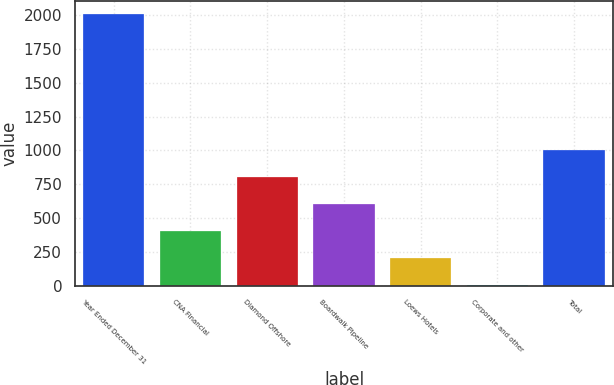Convert chart. <chart><loc_0><loc_0><loc_500><loc_500><bar_chart><fcel>Year Ended December 31<fcel>CNA Financial<fcel>Diamond Offshore<fcel>Boardwalk Pipeline<fcel>Loews Hotels<fcel>Corporate and other<fcel>Total<nl><fcel>2008<fcel>405.6<fcel>806.2<fcel>605.9<fcel>205.3<fcel>5<fcel>1006.5<nl></chart> 